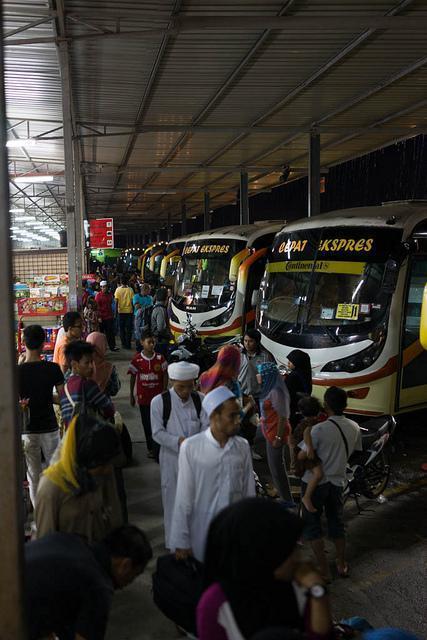How many people are wearing a white hat?
Give a very brief answer. 2. How many people are in the picture?
Give a very brief answer. 10. How many buses are there?
Give a very brief answer. 2. How many big bear are there in the image?
Give a very brief answer. 0. 